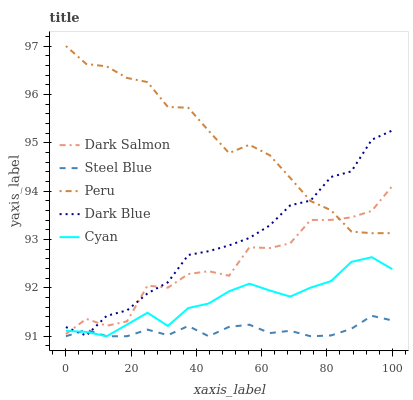Does Steel Blue have the minimum area under the curve?
Answer yes or no. Yes. Does Peru have the maximum area under the curve?
Answer yes or no. Yes. Does Cyan have the minimum area under the curve?
Answer yes or no. No. Does Cyan have the maximum area under the curve?
Answer yes or no. No. Is Steel Blue the smoothest?
Answer yes or no. Yes. Is Dark Salmon the roughest?
Answer yes or no. Yes. Is Cyan the smoothest?
Answer yes or no. No. Is Cyan the roughest?
Answer yes or no. No. Does Cyan have the lowest value?
Answer yes or no. Yes. Does Dark Salmon have the lowest value?
Answer yes or no. No. Does Peru have the highest value?
Answer yes or no. Yes. Does Cyan have the highest value?
Answer yes or no. No. Is Steel Blue less than Dark Salmon?
Answer yes or no. Yes. Is Peru greater than Cyan?
Answer yes or no. Yes. Does Dark Blue intersect Steel Blue?
Answer yes or no. Yes. Is Dark Blue less than Steel Blue?
Answer yes or no. No. Is Dark Blue greater than Steel Blue?
Answer yes or no. No. Does Steel Blue intersect Dark Salmon?
Answer yes or no. No. 